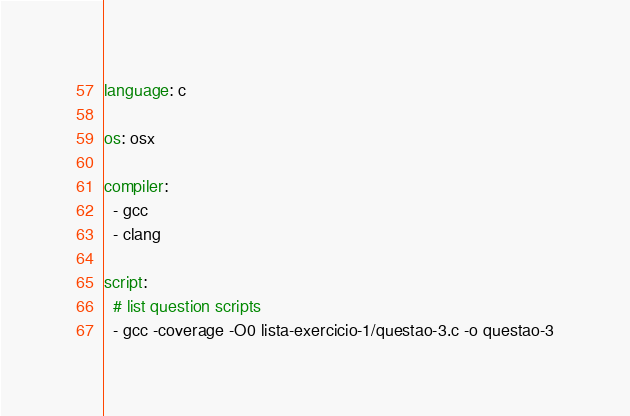<code> <loc_0><loc_0><loc_500><loc_500><_YAML_>language: c

os: osx

compiler:
  - gcc
  - clang

script:
  # list question scripts
  - gcc -coverage -O0 lista-exercicio-1/questao-3.c -o questao-3</code> 